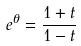Convert formula to latex. <formula><loc_0><loc_0><loc_500><loc_500>e ^ { \theta } = \frac { 1 + t } { 1 - t }</formula> 